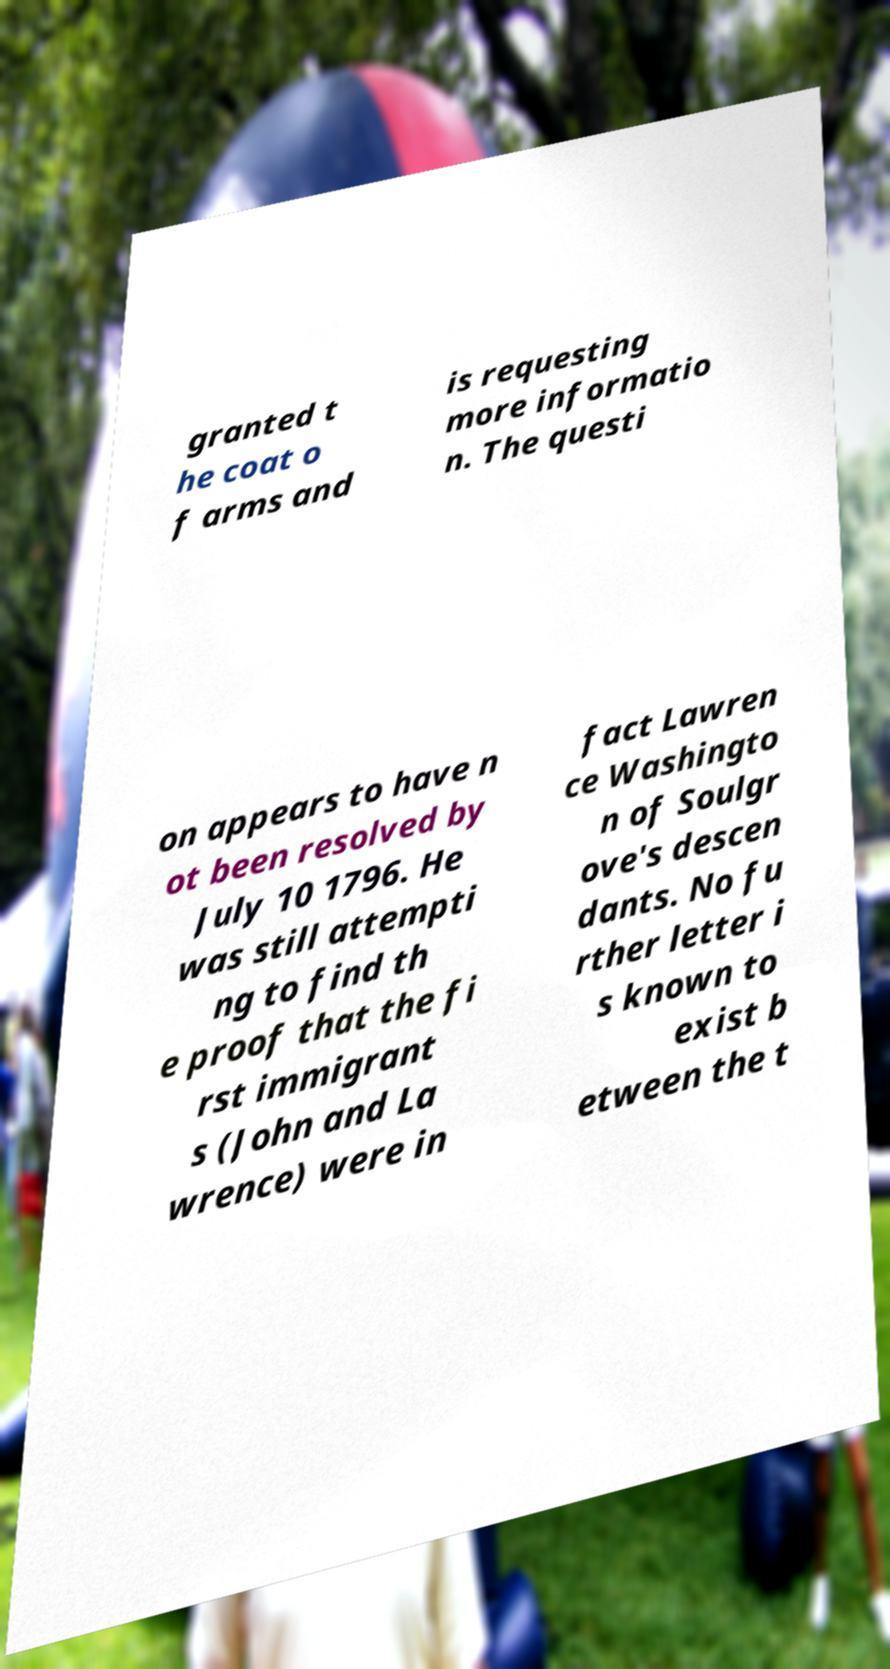Please identify and transcribe the text found in this image. granted t he coat o f arms and is requesting more informatio n. The questi on appears to have n ot been resolved by July 10 1796. He was still attempti ng to find th e proof that the fi rst immigrant s (John and La wrence) were in fact Lawren ce Washingto n of Soulgr ove's descen dants. No fu rther letter i s known to exist b etween the t 